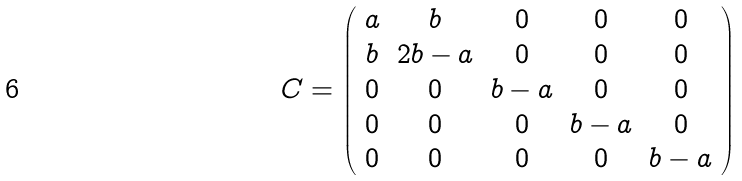<formula> <loc_0><loc_0><loc_500><loc_500>C = \left ( \begin{array} { c c c c c } a & b & 0 & 0 & 0 \\ b & 2 b - a & 0 & 0 & 0 \\ 0 & 0 & b - a & 0 & 0 \\ 0 & 0 & 0 & b - a & 0 \\ 0 & 0 & 0 & 0 & b - a \\ \end{array} \right )</formula> 